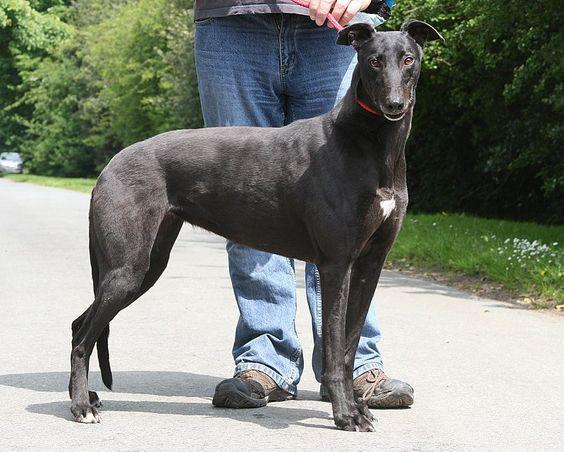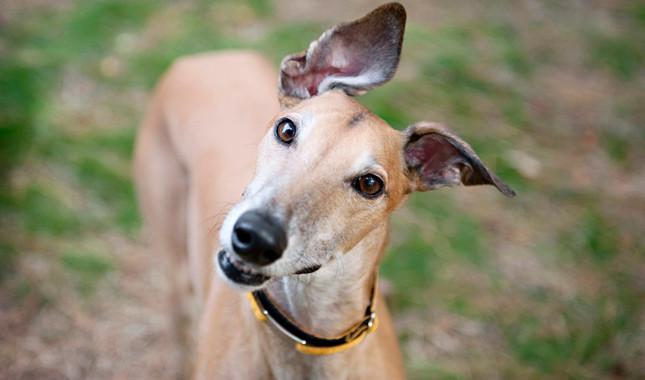The first image is the image on the left, the second image is the image on the right. Analyze the images presented: Is the assertion "A person is with at least one dog in the grass in one of the pictures." valid? Answer yes or no. No. The first image is the image on the left, the second image is the image on the right. Analyze the images presented: Is the assertion "An image shows a human hand touching the head of a hound wearing a bandana." valid? Answer yes or no. No. 